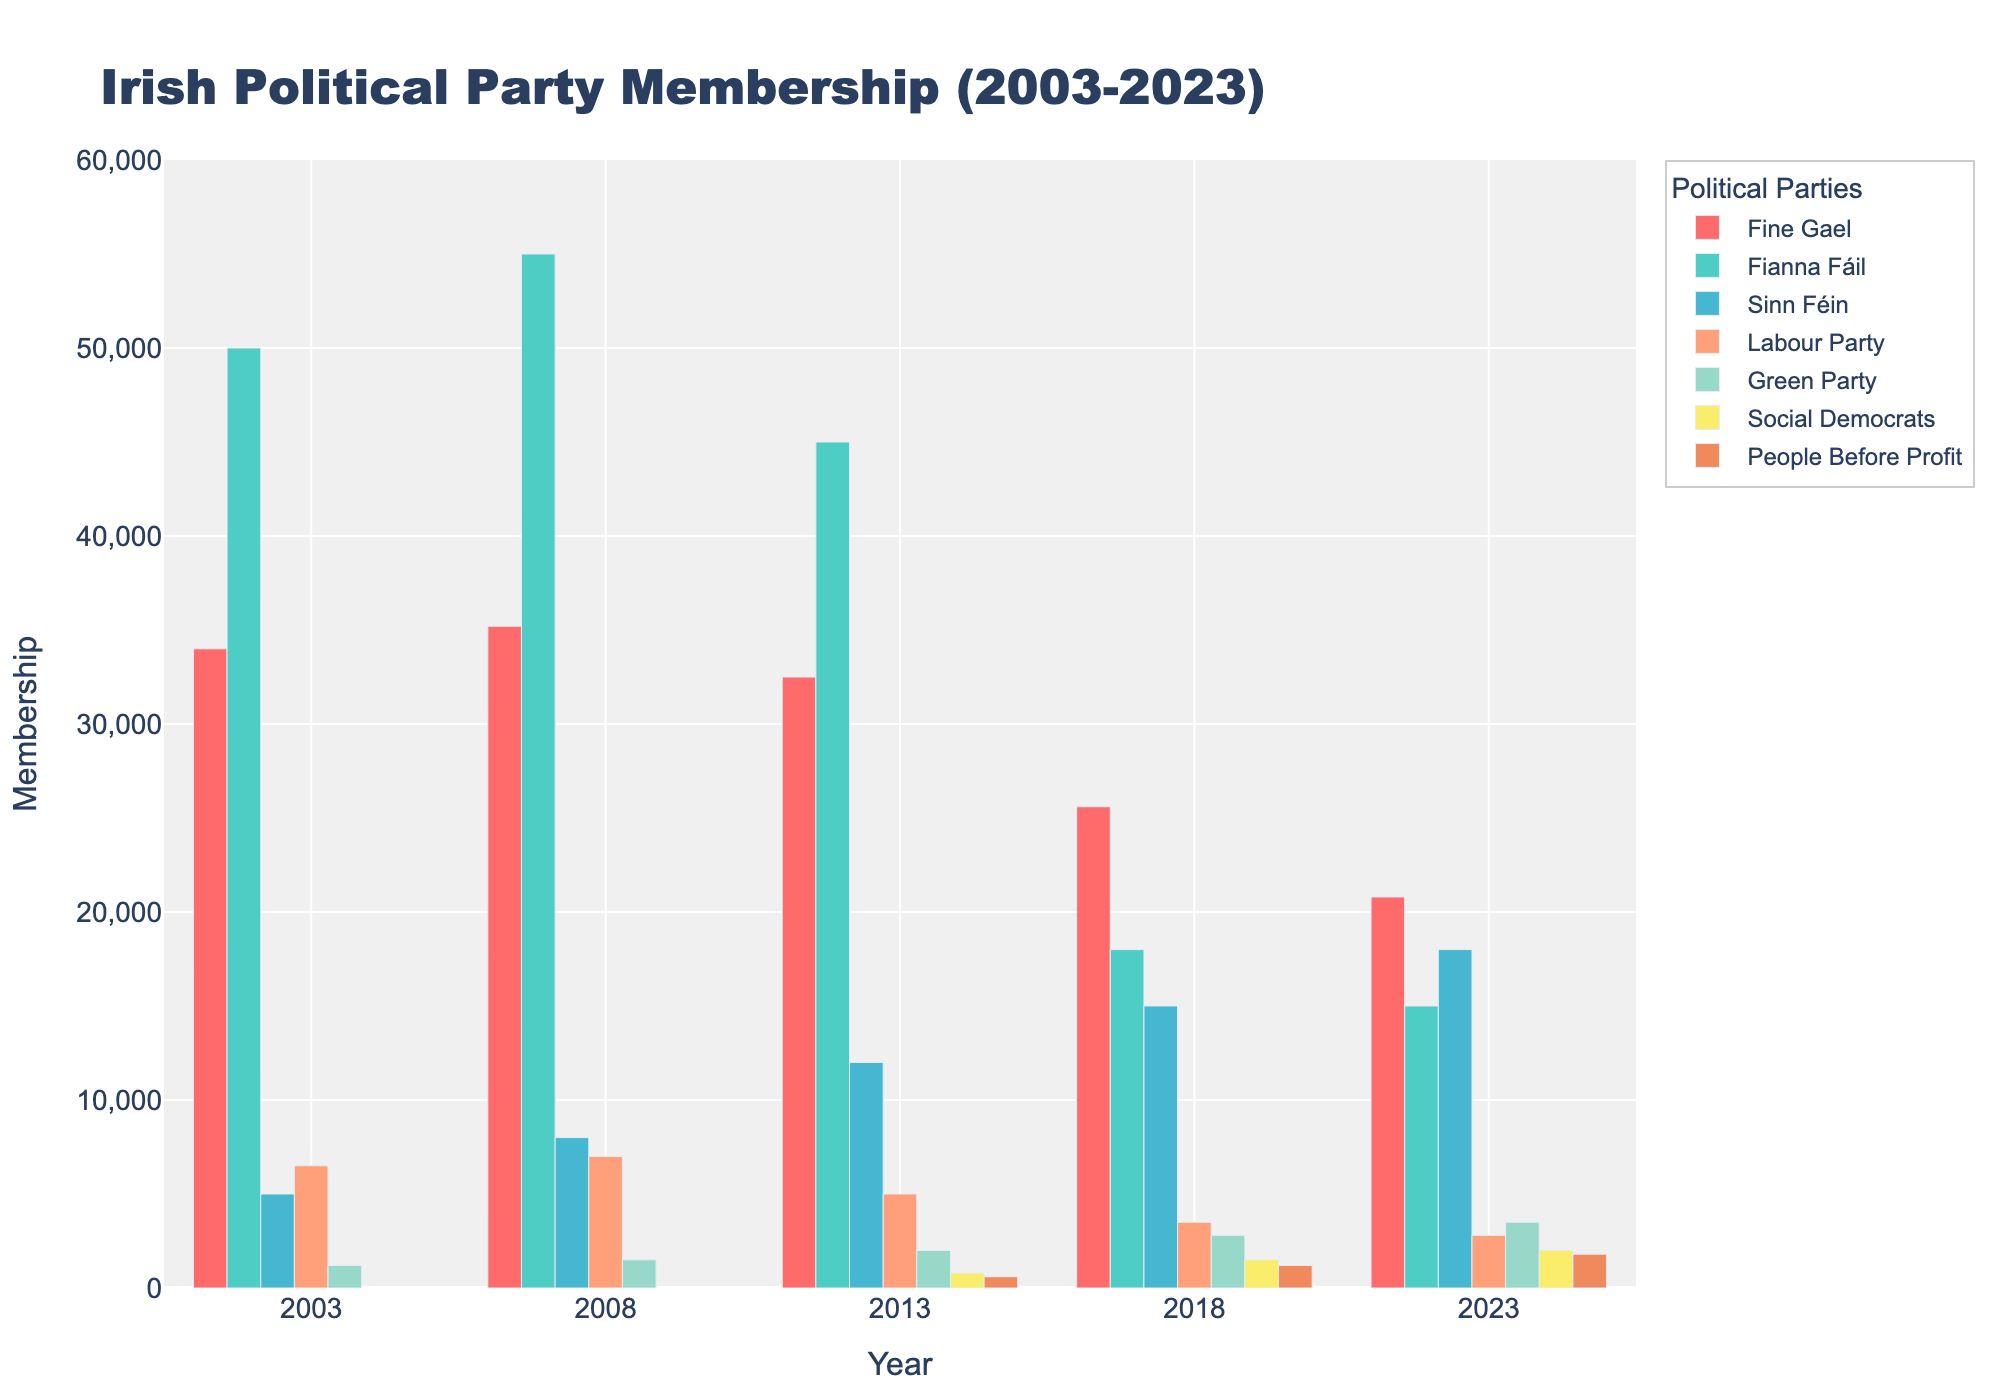Which party had the highest membership in 2003? Looking at the bars representing 2003, the highest bar corresponds to Fianna Fáil.
Answer: Fianna Fáil Between 2008 and 2013, which party showed the largest decrease in membership? Comparing the heights of the bars between 2008 and 2013, Fianna Fáil shows the largest drop.
Answer: Fianna Fáil How does the 2023 membership of Sinn Féin compare to its 2003 membership? The bar for Sinn Féin in 2023 is significantly higher than its 2003 bar.
Answer: Higher Which party had the lowest membership in 2008? The shortest bar in 2008 represents the Green Party.
Answer: Green Party Calculate the average membership for Fine Gael over the given years. Sum the memberships for Fine Gael (34000 + 35200 + 32500 + 25600 + 20800) = 148100, and divide by the number of years (5): 148100 / 5 = 29620
Answer: 29620 Which year did the Labour Party experience the largest percentage decrease in membership compared to the previous recorded year? Calculate percentage decreases: 2013-2008: (7000-5000)/7000 * 100 = 28.57%, 2018-2013: (5000-3500)/5000 * 100 = 30%, 2023-2018: (3500-2800)/3500 * 100 = 20%. The largest is between 2013 and 2018.
Answer: 2018 Which parties have shown a continuous increase in membership over the recorded years without any decrease? Check the bars for every year for each party: Sinn Féin, Green Party, Social Democrats, and People Before Profit have consistently rising bars.
Answer: Sinn Féin, Green Party, Social Democrats, People Before Profit Which year did Fianna Fáil's membership drop below 20,000? The membership for Fianna Fáil drops below 20,000 in 2018 and remains below in 2023.
Answer: 2018 What is the combined membership of Social Democrats and People Before Profit in 2023? Add the 2023 memberships for Social Democrats and People Before Profit: 2000 + 1800 = 3800.
Answer: 3800 From 2003 to 2023, which party has the most stable membership numbers? Stability is determined by the smallest range. Calculate the range (max - min) for each party: Fine Gael: 35200-20800=14400, Fianna Fáil: 55000-15000=40000, Sinn Féin: 18000-5000=13000, Labour Party: 7000-2800=4200, Green Party: 3500-1200=2300. The Green Party has the smallest range.
Answer: Green Party 